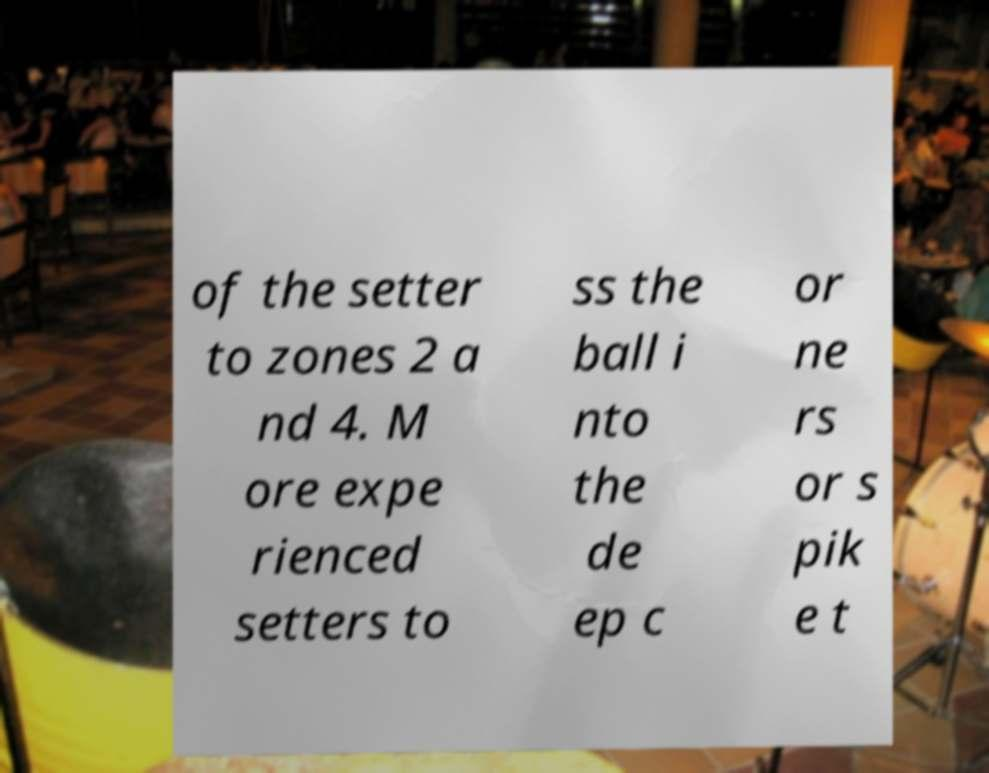Can you accurately transcribe the text from the provided image for me? of the setter to zones 2 a nd 4. M ore expe rienced setters to ss the ball i nto the de ep c or ne rs or s pik e t 